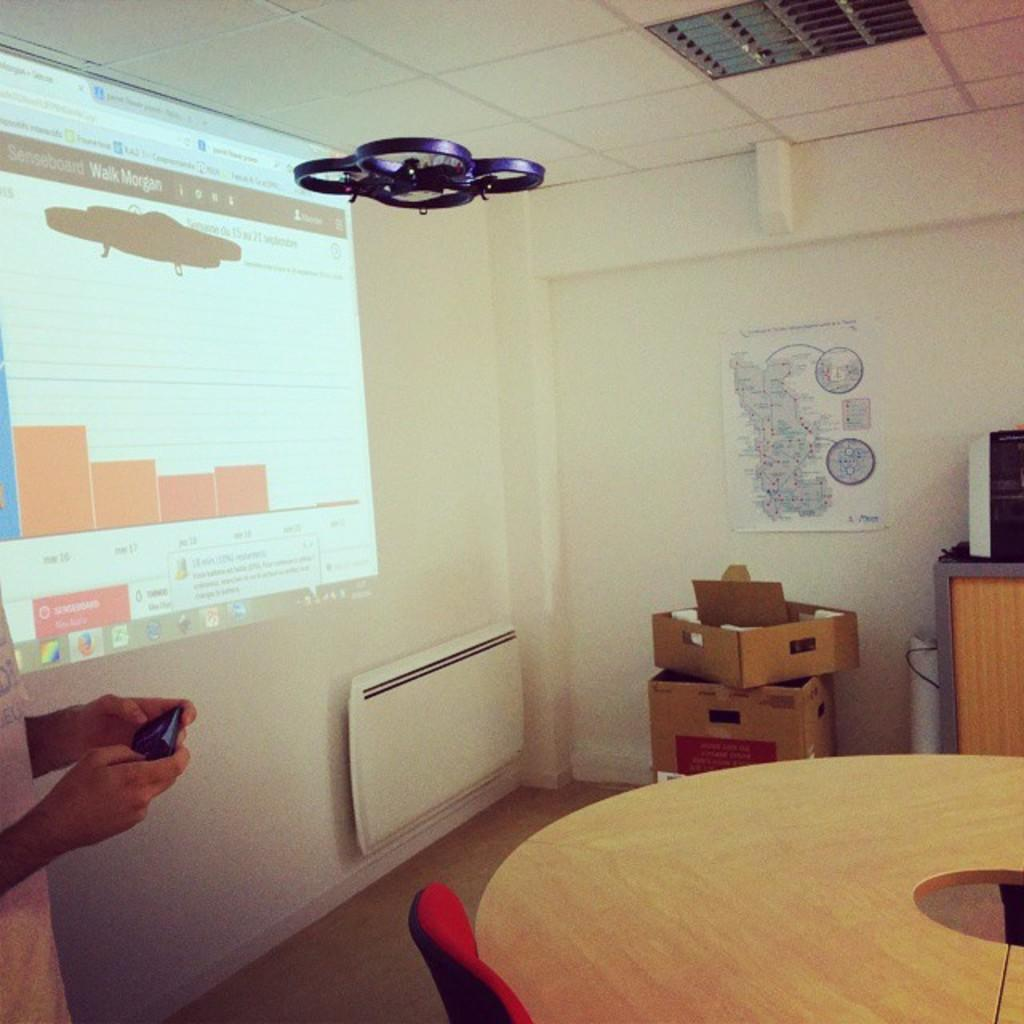What is on the wall in the image? There is a projector screen on the wall. What piece of furniture is present in the image? There is a table in the image. What type of seating is visible in the image? There is a chair in the image. How many stomachs can be seen in the image? There are no stomachs present in the image. Is there a bridge visible in the image? No, there is no bridge present in the image. 